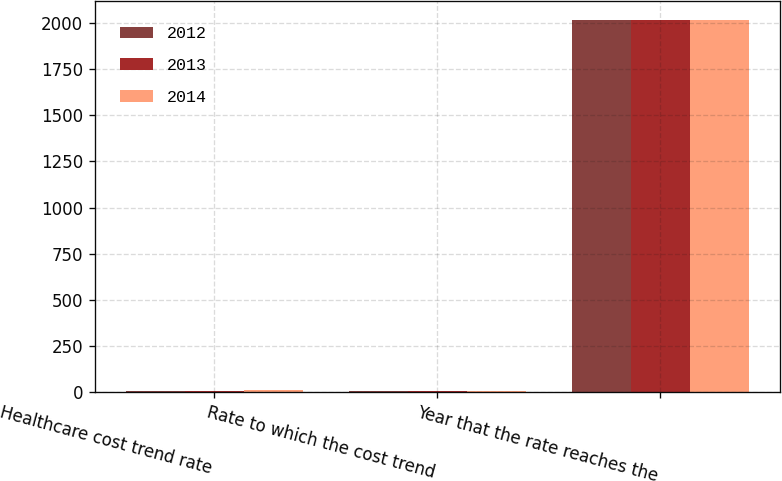Convert chart. <chart><loc_0><loc_0><loc_500><loc_500><stacked_bar_chart><ecel><fcel>Healthcare cost trend rate<fcel>Rate to which the cost trend<fcel>Year that the rate reaches the<nl><fcel>2012<fcel>6<fcel>4.5<fcel>2018<nl><fcel>2013<fcel>6.4<fcel>4.5<fcel>2019<nl><fcel>2014<fcel>6.8<fcel>4.5<fcel>2018<nl></chart> 